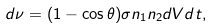Convert formula to latex. <formula><loc_0><loc_0><loc_500><loc_500>d \nu = ( 1 - \cos { \theta } ) \sigma n _ { 1 } n _ { 2 } d V d t ,</formula> 